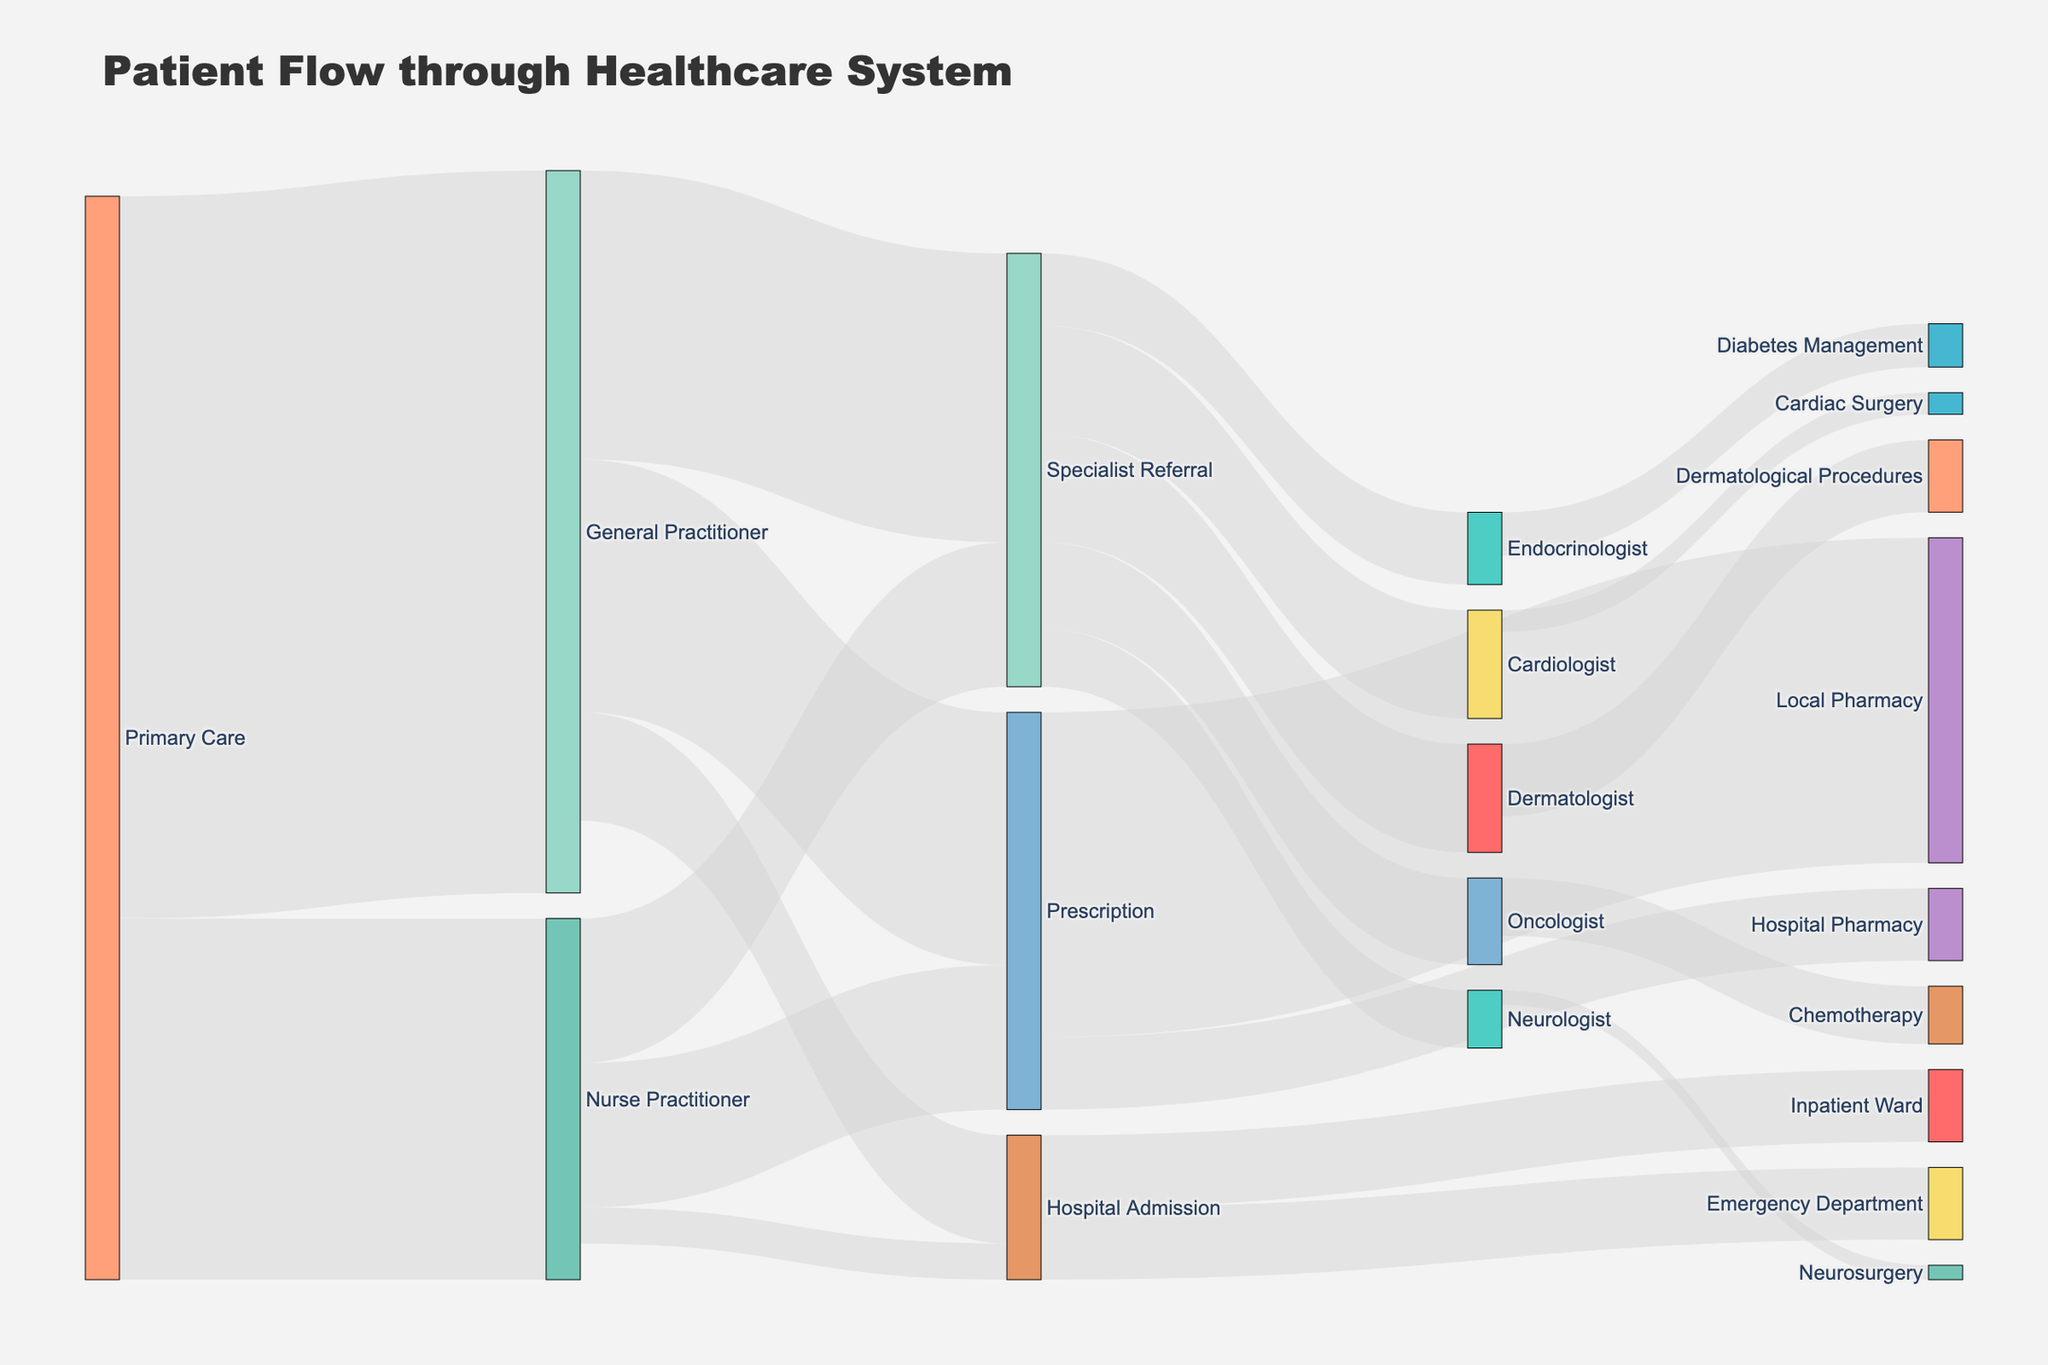What is the title of the figure? The title is usually found at the top of the figure, which states what the figure is about.
Answer: "Patient Flow through Healthcare System" How many patient flows originate from Primary Care? To determine this, count the number of distinct targets flowing from the source "Primary Care."
Answer: 2 What is the total number of patients referred to a Specialist from General Practitioner? Look for flows that originate from "General Practitioner" and terminate at "Specialist Referral," then sum these values. 400 patients are referred to a specialist by the General Practitioner.
Answer: 400 Which specialist among Cardiologist, Endocrinologist, Neurologist, Oncologist, and Dermatologist receives the most referrals? Compare the values of patient flows directed towards each of these specialists from the "Specialist Referral" node.
Answer: Dermatologist What is the total number of prescriptions provided by Primary Care? Sum the values for all flows into "Prescription" nodes originating from both "General Practitioner" and "Nurse Practitioner."
Answer: 550 How does the number of hospital admissions from Nurse Practitioners compare to those from General Practitioners? Compare the flow values between "Hospital Admission" from "General Practitioner" and "Nurse Practitioner." 150 patients are referred by General Practitioner and 50 by Nurse Practitioner. The difference is 150 - 50 = 100.
Answer: General Practitioner refers 100 more patients to the hospital How many patients initially see a Nurse Practitioner? Simply refer to the flow value from "Primary Care" to "Nurse Practitioner."
Answer: 500 What is the total flow from Specialist Referral to various specialists? Sum the values of patient flows going to Cardiologist, Endocrinologist, Neurologist, Oncologist, and Dermatologist. 150 + 100 + 80 + 120 + 150 = 600.
Answer: 600 Identify the relationship between patients seeing a General Practitioner versus a Nurse Practitioner for the flow into Hospital Admission. Compare the values of patient flows into "Hospital Admission" from both "General Practitioner" (150) and "Nurse Practitioner" (50).
Answer: General Practitioner sends more patients What is the total number of patients experiencing surgical procedures (Cardiac Surgery and Neurosurgery)? Sum the values of patient flows to "Cardiac Surgery" and "Neurosurgery" from their respective specialists. 30 + 20 = 50.
Answer: 50 